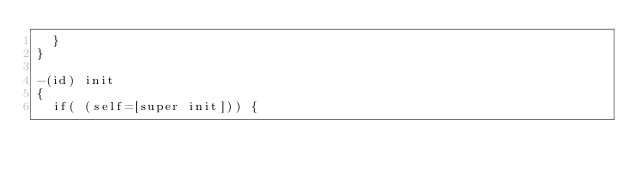<code> <loc_0><loc_0><loc_500><loc_500><_ObjectiveC_>	}
}

-(id) init
{
	if( (self=[super init])) {
		</code> 